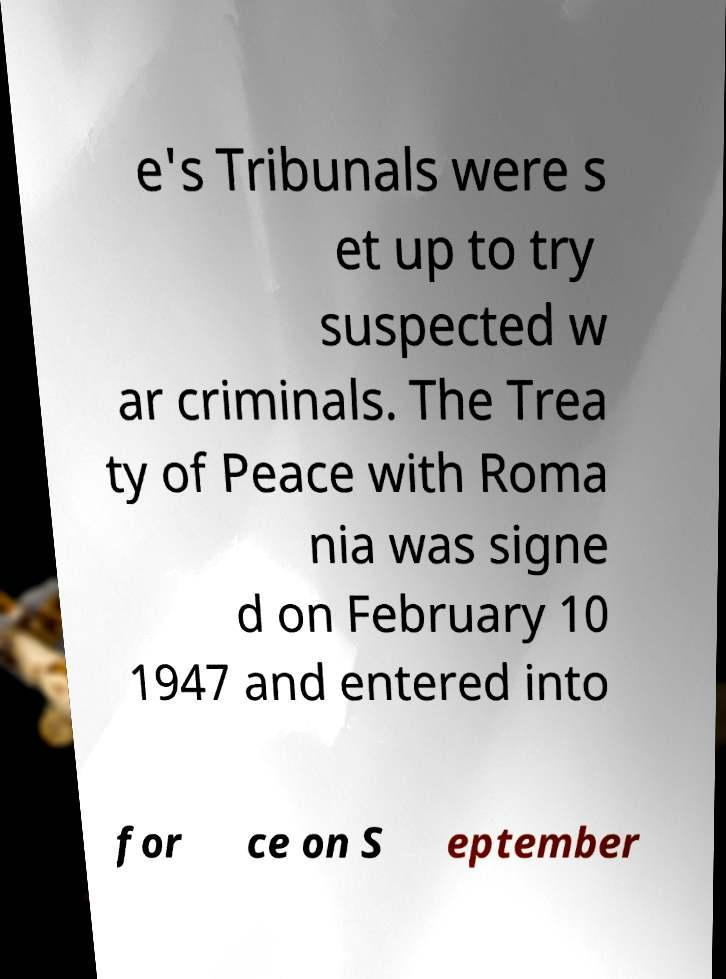I need the written content from this picture converted into text. Can you do that? e's Tribunals were s et up to try suspected w ar criminals. The Trea ty of Peace with Roma nia was signe d on February 10 1947 and entered into for ce on S eptember 